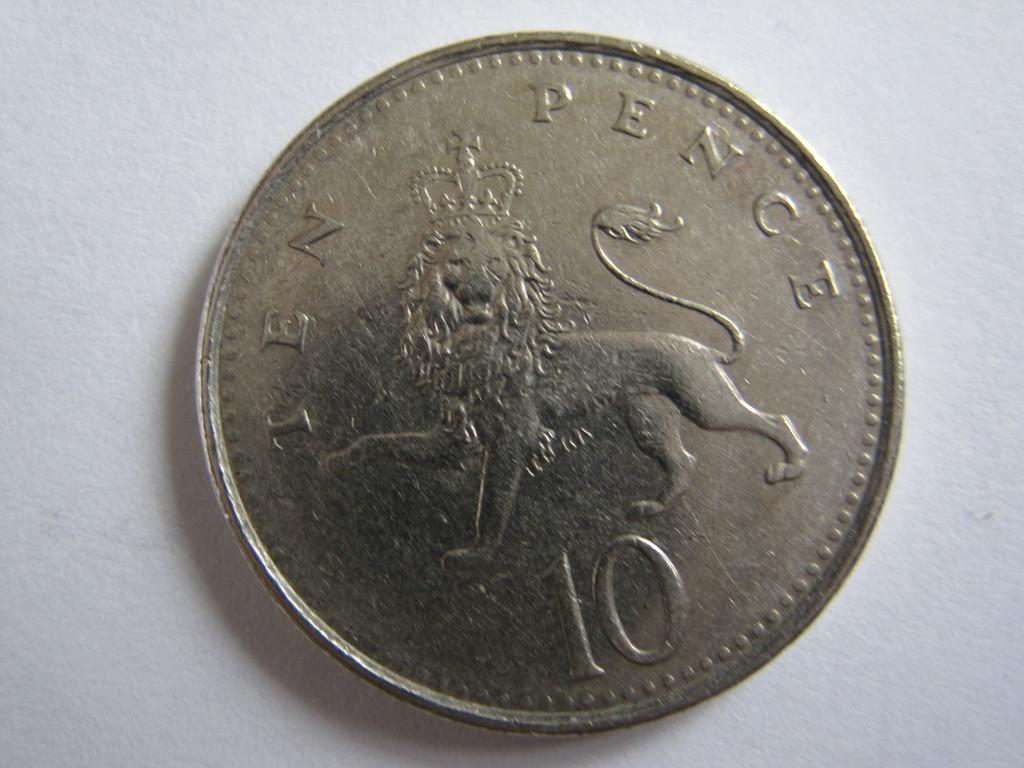How much is the coin worth?
Your answer should be compact. 10 pence. 